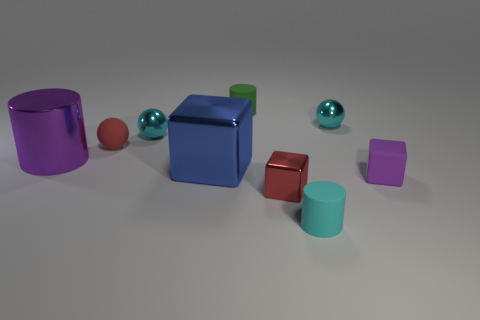Add 1 big blue things. How many objects exist? 10 Subtract all blocks. How many objects are left? 6 Add 1 purple rubber cubes. How many purple rubber cubes are left? 2 Add 3 green matte things. How many green matte things exist? 4 Subtract 0 gray balls. How many objects are left? 9 Subtract all red matte spheres. Subtract all large purple things. How many objects are left? 7 